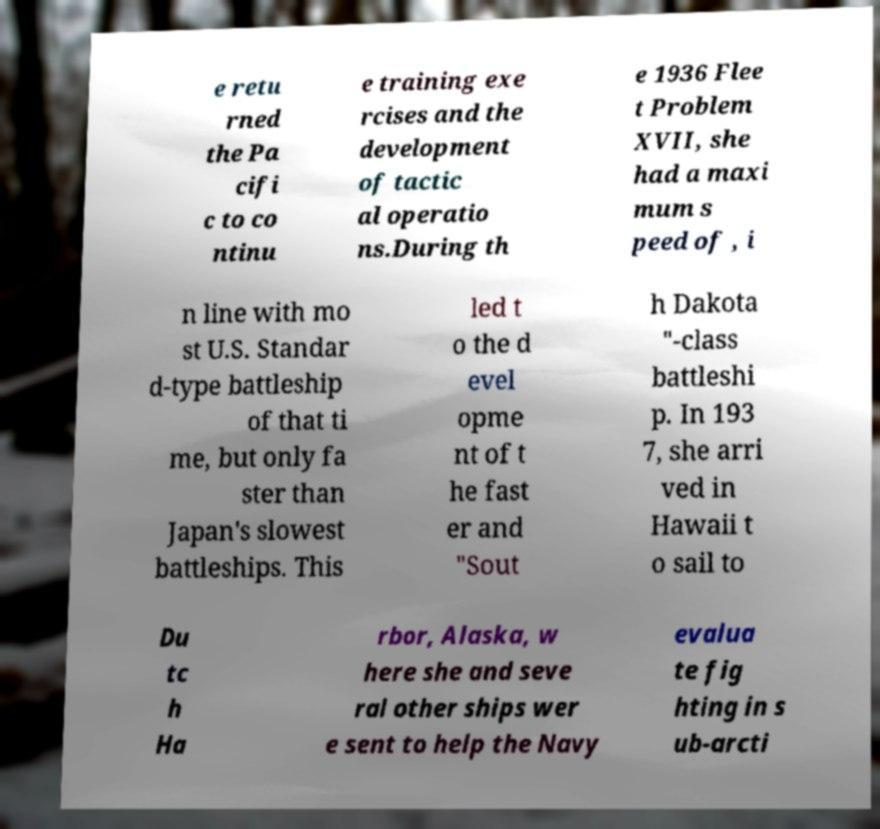There's text embedded in this image that I need extracted. Can you transcribe it verbatim? e retu rned the Pa cifi c to co ntinu e training exe rcises and the development of tactic al operatio ns.During th e 1936 Flee t Problem XVII, she had a maxi mum s peed of , i n line with mo st U.S. Standar d-type battleship of that ti me, but only fa ster than Japan's slowest battleships. This led t o the d evel opme nt of t he fast er and "Sout h Dakota "-class battleshi p. In 193 7, she arri ved in Hawaii t o sail to Du tc h Ha rbor, Alaska, w here she and seve ral other ships wer e sent to help the Navy evalua te fig hting in s ub-arcti 